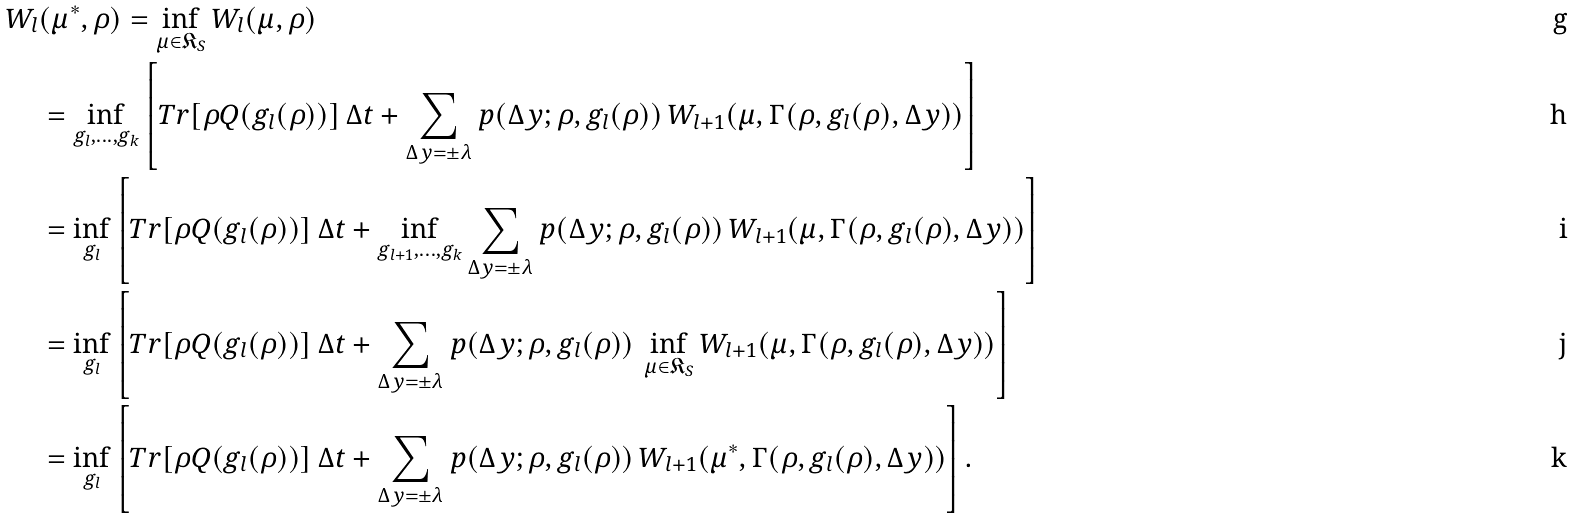Convert formula to latex. <formula><loc_0><loc_0><loc_500><loc_500>W _ { l } & ( \mu ^ { * } , \rho ) = \inf _ { \mu \in \mathfrak { K } _ { S } } W _ { l } ( \mu , \rho ) \\ & = \inf _ { g _ { l } , \dots , g _ { k } } \left [ T r [ \rho Q ( g _ { l } ( \rho ) ) ] \, \Delta t + \sum _ { \Delta y = \pm \lambda } p ( \Delta y ; \rho , g _ { l } ( \rho ) ) \, W _ { l + 1 } ( \mu , \Gamma ( \rho , g _ { l } ( \rho ) , \Delta y ) ) \right ] \\ & = \inf _ { g _ { l } } \left [ T r [ \rho Q ( g _ { l } ( \rho ) ) ] \, \Delta t + \inf _ { g _ { l + 1 } , \dots , g _ { k } } \sum _ { \Delta y = \pm \lambda } p ( \Delta y ; \rho , g _ { l } ( \rho ) ) \, W _ { l + 1 } ( \mu , \Gamma ( \rho , g _ { l } ( \rho ) , \Delta y ) ) \right ] \\ & = \inf _ { g _ { l } } \left [ T r [ \rho Q ( g _ { l } ( \rho ) ) ] \, \Delta t + \sum _ { \Delta y = \pm \lambda } p ( \Delta y ; \rho , g _ { l } ( \rho ) ) \, \inf _ { \mu \in \mathfrak { K } _ { S } } W _ { l + 1 } ( \mu , \Gamma ( \rho , g _ { l } ( \rho ) , \Delta y ) ) \right ] \\ & = \inf _ { g _ { l } } \left [ T r [ \rho Q ( g _ { l } ( \rho ) ) ] \, \Delta t + \sum _ { \Delta y = \pm \lambda } p ( \Delta y ; \rho , g _ { l } ( \rho ) ) \, W _ { l + 1 } ( \mu ^ { * } , \Gamma ( \rho , g _ { l } ( \rho ) , \Delta y ) ) \right ] .</formula> 